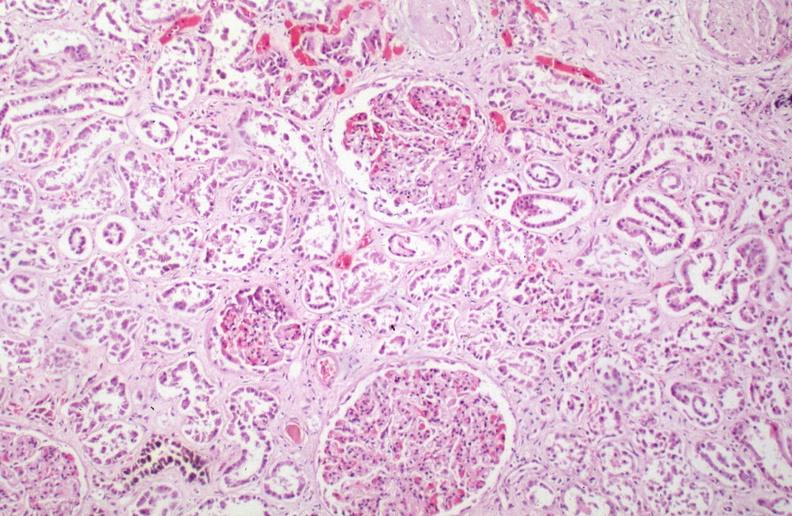s hemosiderosis caused by numerous blood transfusions?
Answer the question using a single word or phrase. Yes 